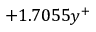Convert formula to latex. <formula><loc_0><loc_0><loc_500><loc_500>+ 1 . 7 0 5 5 y ^ { + }</formula> 